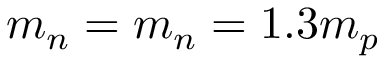Convert formula to latex. <formula><loc_0><loc_0><loc_500><loc_500>m _ { n } = m _ { n } = 1 . 3 m _ { p }</formula> 